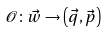Convert formula to latex. <formula><loc_0><loc_0><loc_500><loc_500>\mathcal { O } \colon \vec { w } \to \left ( \vec { q } , \vec { p } \right )</formula> 